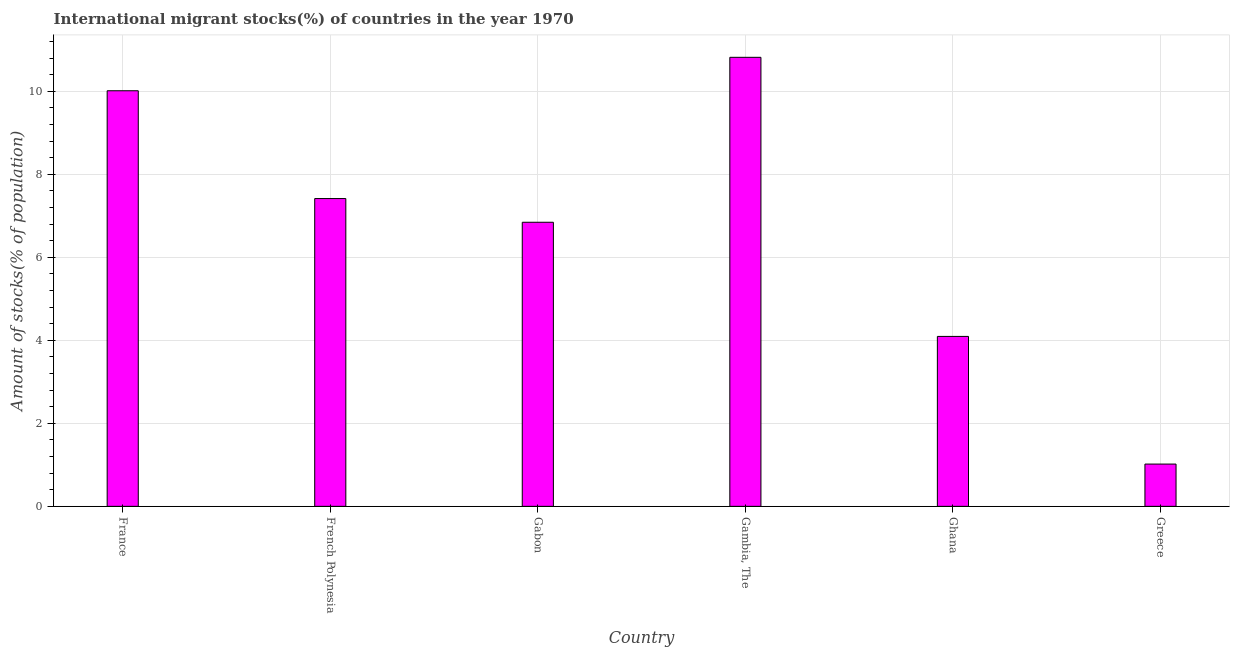Does the graph contain any zero values?
Offer a terse response. No. What is the title of the graph?
Your answer should be very brief. International migrant stocks(%) of countries in the year 1970. What is the label or title of the X-axis?
Provide a short and direct response. Country. What is the label or title of the Y-axis?
Make the answer very short. Amount of stocks(% of population). What is the number of international migrant stocks in France?
Your answer should be compact. 10.01. Across all countries, what is the maximum number of international migrant stocks?
Your answer should be compact. 10.82. Across all countries, what is the minimum number of international migrant stocks?
Make the answer very short. 1.02. In which country was the number of international migrant stocks maximum?
Ensure brevity in your answer.  Gambia, The. What is the sum of the number of international migrant stocks?
Your answer should be compact. 40.2. What is the difference between the number of international migrant stocks in France and Ghana?
Your answer should be compact. 5.92. What is the average number of international migrant stocks per country?
Provide a succinct answer. 6.7. What is the median number of international migrant stocks?
Provide a short and direct response. 7.13. In how many countries, is the number of international migrant stocks greater than 10.4 %?
Provide a succinct answer. 1. What is the ratio of the number of international migrant stocks in Gabon to that in Greece?
Keep it short and to the point. 6.72. Is the number of international migrant stocks in French Polynesia less than that in Gabon?
Offer a very short reply. No. Is the difference between the number of international migrant stocks in France and Ghana greater than the difference between any two countries?
Offer a very short reply. No. What is the difference between the highest and the second highest number of international migrant stocks?
Provide a succinct answer. 0.81. Is the sum of the number of international migrant stocks in Gabon and Greece greater than the maximum number of international migrant stocks across all countries?
Your answer should be compact. No. How many bars are there?
Make the answer very short. 6. How many countries are there in the graph?
Provide a short and direct response. 6. What is the difference between two consecutive major ticks on the Y-axis?
Your response must be concise. 2. Are the values on the major ticks of Y-axis written in scientific E-notation?
Offer a terse response. No. What is the Amount of stocks(% of population) of France?
Your response must be concise. 10.01. What is the Amount of stocks(% of population) of French Polynesia?
Your answer should be compact. 7.42. What is the Amount of stocks(% of population) of Gabon?
Your response must be concise. 6.84. What is the Amount of stocks(% of population) in Gambia, The?
Give a very brief answer. 10.82. What is the Amount of stocks(% of population) of Ghana?
Ensure brevity in your answer.  4.09. What is the Amount of stocks(% of population) of Greece?
Give a very brief answer. 1.02. What is the difference between the Amount of stocks(% of population) in France and French Polynesia?
Provide a short and direct response. 2.6. What is the difference between the Amount of stocks(% of population) in France and Gabon?
Keep it short and to the point. 3.17. What is the difference between the Amount of stocks(% of population) in France and Gambia, The?
Make the answer very short. -0.81. What is the difference between the Amount of stocks(% of population) in France and Ghana?
Your response must be concise. 5.92. What is the difference between the Amount of stocks(% of population) in France and Greece?
Your answer should be very brief. 8.99. What is the difference between the Amount of stocks(% of population) in French Polynesia and Gabon?
Your answer should be very brief. 0.57. What is the difference between the Amount of stocks(% of population) in French Polynesia and Gambia, The?
Provide a short and direct response. -3.4. What is the difference between the Amount of stocks(% of population) in French Polynesia and Ghana?
Keep it short and to the point. 3.32. What is the difference between the Amount of stocks(% of population) in French Polynesia and Greece?
Provide a short and direct response. 6.4. What is the difference between the Amount of stocks(% of population) in Gabon and Gambia, The?
Your response must be concise. -3.97. What is the difference between the Amount of stocks(% of population) in Gabon and Ghana?
Your answer should be very brief. 2.75. What is the difference between the Amount of stocks(% of population) in Gabon and Greece?
Provide a short and direct response. 5.83. What is the difference between the Amount of stocks(% of population) in Gambia, The and Ghana?
Make the answer very short. 6.72. What is the difference between the Amount of stocks(% of population) in Gambia, The and Greece?
Make the answer very short. 9.8. What is the difference between the Amount of stocks(% of population) in Ghana and Greece?
Provide a succinct answer. 3.08. What is the ratio of the Amount of stocks(% of population) in France to that in French Polynesia?
Offer a very short reply. 1.35. What is the ratio of the Amount of stocks(% of population) in France to that in Gabon?
Make the answer very short. 1.46. What is the ratio of the Amount of stocks(% of population) in France to that in Gambia, The?
Give a very brief answer. 0.93. What is the ratio of the Amount of stocks(% of population) in France to that in Ghana?
Keep it short and to the point. 2.45. What is the ratio of the Amount of stocks(% of population) in France to that in Greece?
Provide a succinct answer. 9.83. What is the ratio of the Amount of stocks(% of population) in French Polynesia to that in Gabon?
Give a very brief answer. 1.08. What is the ratio of the Amount of stocks(% of population) in French Polynesia to that in Gambia, The?
Ensure brevity in your answer.  0.69. What is the ratio of the Amount of stocks(% of population) in French Polynesia to that in Ghana?
Provide a short and direct response. 1.81. What is the ratio of the Amount of stocks(% of population) in French Polynesia to that in Greece?
Your response must be concise. 7.28. What is the ratio of the Amount of stocks(% of population) in Gabon to that in Gambia, The?
Keep it short and to the point. 0.63. What is the ratio of the Amount of stocks(% of population) in Gabon to that in Ghana?
Your answer should be very brief. 1.67. What is the ratio of the Amount of stocks(% of population) in Gabon to that in Greece?
Provide a short and direct response. 6.72. What is the ratio of the Amount of stocks(% of population) in Gambia, The to that in Ghana?
Make the answer very short. 2.64. What is the ratio of the Amount of stocks(% of population) in Gambia, The to that in Greece?
Provide a short and direct response. 10.62. What is the ratio of the Amount of stocks(% of population) in Ghana to that in Greece?
Provide a succinct answer. 4.02. 